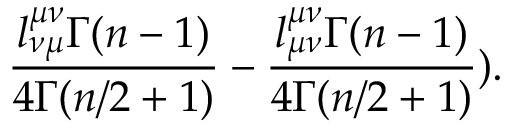<formula> <loc_0><loc_0><loc_500><loc_500>\frac { l _ { \nu \mu } ^ { \mu \nu } \Gamma ( n - 1 ) } { 4 \Gamma ( n / 2 + 1 ) } - \frac { l _ { \mu \nu } ^ { \mu \nu } \Gamma ( n - 1 ) } { 4 \Gamma ( n / 2 + 1 ) } ) .</formula> 